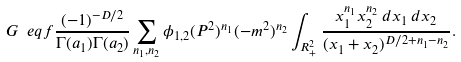Convert formula to latex. <formula><loc_0><loc_0><loc_500><loc_500>G \ e q f \frac { ( - 1 ) ^ { - D / 2 } } { \Gamma ( a _ { 1 } ) \Gamma ( a _ { 2 } ) } \sum _ { n _ { 1 } , n _ { 2 } } \phi _ { 1 , 2 } ( P ^ { 2 } ) ^ { n _ { 1 } } ( - m ^ { 2 } ) ^ { n _ { 2 } } \int _ { R ^ { 2 } _ { + } } \frac { x _ { 1 } ^ { n _ { 1 } } x _ { 2 } ^ { n _ { 2 } } \, d x _ { 1 } \, d x _ { 2 } } { ( x _ { 1 } + x _ { 2 } ) ^ { D / 2 + n _ { 1 } - n _ { 2 } } } .</formula> 